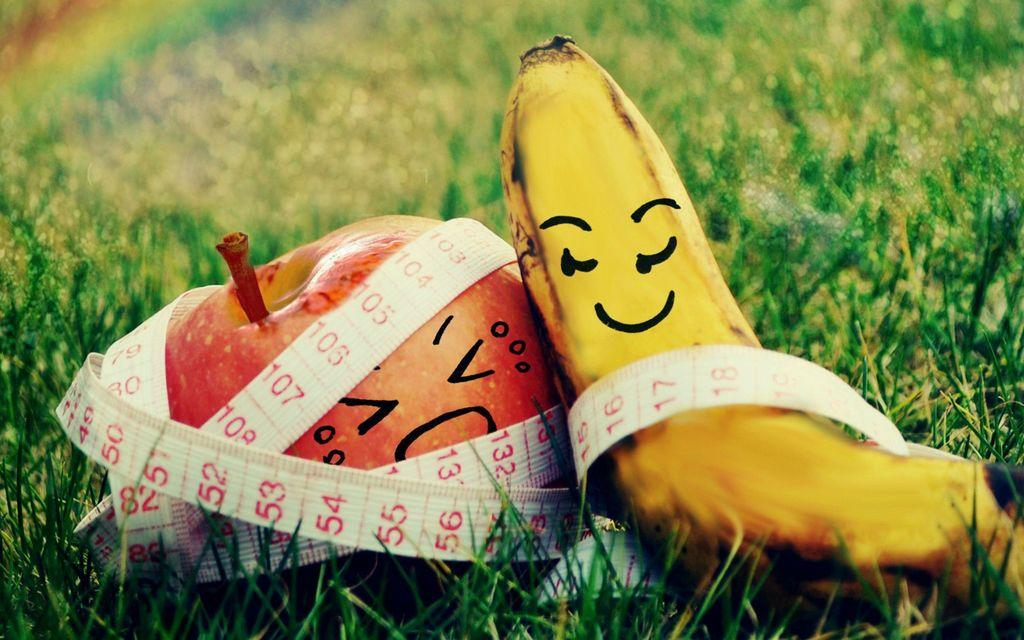What type of fruits are in the image? There is a banana and an apple in the image. Where are the fruits located? The banana and apple are on the grass. What is wrapped around the fruits? A measuring tape is wrapped around the fruits. How is the background of the fruits depicted? The background of the fruits is blurred. Can you tell me which furniture piece the kitty is sitting on in the image? There is no kitty or furniture present in the image. 